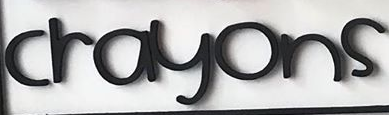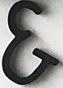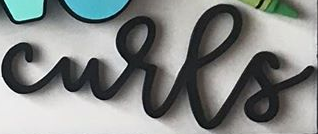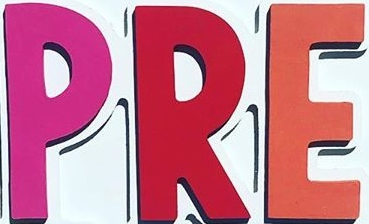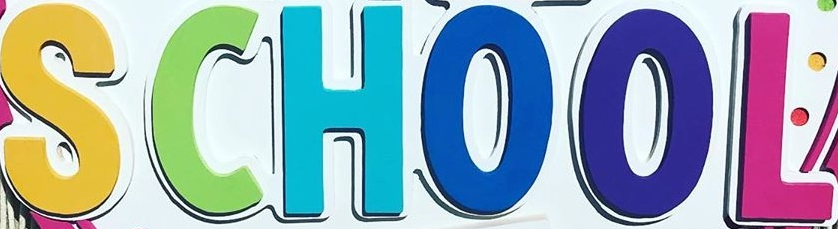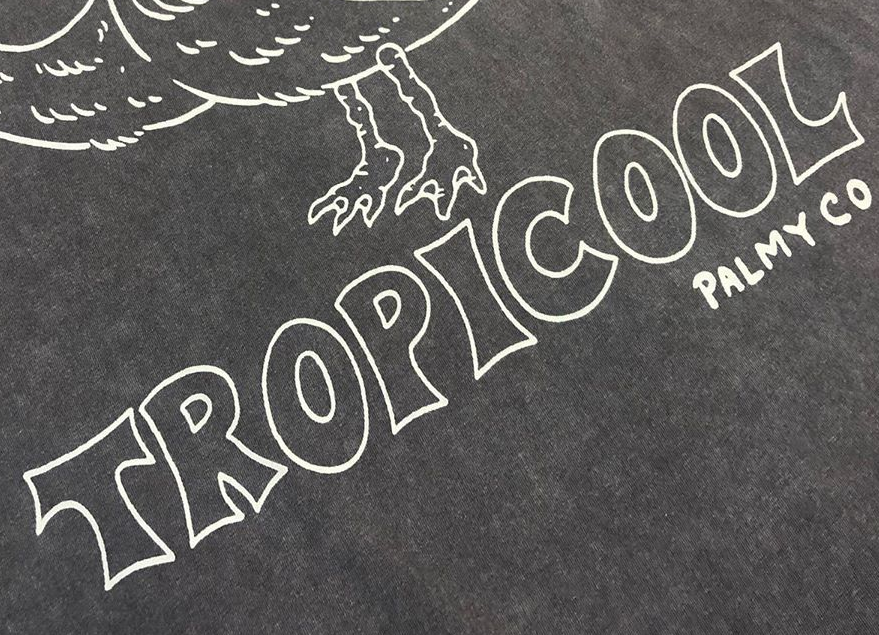What text appears in these images from left to right, separated by a semicolon? crayons; &; curls; PRE; SCHOOL; TROPICOOL 